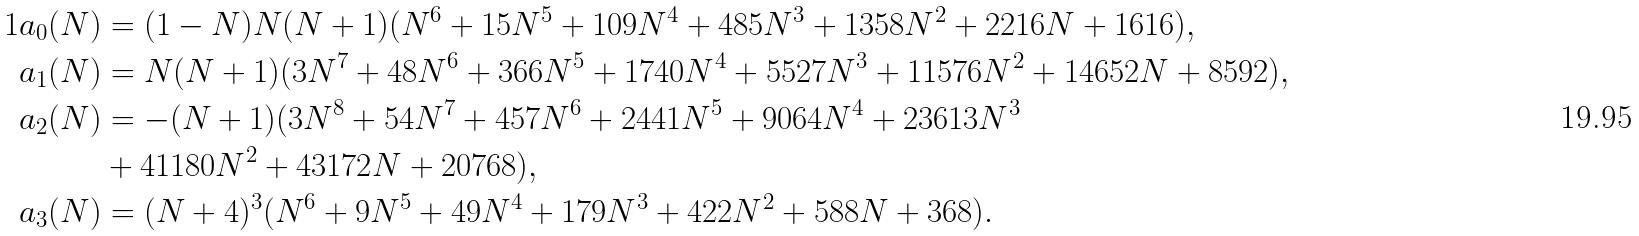<formula> <loc_0><loc_0><loc_500><loc_500>1 a _ { 0 } ( N ) & = ( 1 - N ) N ( N + 1 ) ( N ^ { 6 } + 1 5 N ^ { 5 } + 1 0 9 N ^ { 4 } + 4 8 5 N ^ { 3 } + 1 3 5 8 N ^ { 2 } + 2 2 1 6 N + 1 6 1 6 ) , \\ a _ { 1 } ( N ) & = N ( N + 1 ) ( 3 N ^ { 7 } + 4 8 N ^ { 6 } + 3 6 6 N ^ { 5 } + 1 7 4 0 N ^ { 4 } + 5 5 2 7 N ^ { 3 } + 1 1 5 7 6 N ^ { 2 } + 1 4 6 5 2 N + 8 5 9 2 ) , \\ a _ { 2 } ( N ) & = - ( N + 1 ) ( 3 N ^ { 8 } + 5 4 N ^ { 7 } + 4 5 7 N ^ { 6 } + 2 4 4 1 N ^ { 5 } + 9 0 6 4 N ^ { 4 } + 2 3 6 1 3 N ^ { 3 } \\ & + 4 1 1 8 0 N ^ { 2 } + 4 3 1 7 2 N + 2 0 7 6 8 ) , \\ a _ { 3 } ( N ) & = ( N + 4 ) ^ { 3 } ( N ^ { 6 } + 9 N ^ { 5 } + 4 9 N ^ { 4 } + 1 7 9 N ^ { 3 } + 4 2 2 N ^ { 2 } + 5 8 8 N + 3 6 8 ) .</formula> 